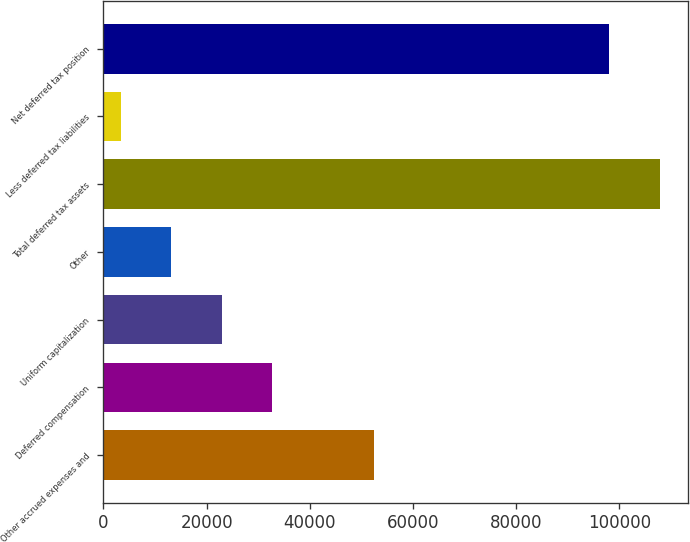<chart> <loc_0><loc_0><loc_500><loc_500><bar_chart><fcel>Other accrued expenses and<fcel>Deferred compensation<fcel>Uniform capitalization<fcel>Other<fcel>Total deferred tax assets<fcel>Less deferred tax liabilities<fcel>Net deferred tax position<nl><fcel>52384<fcel>32728<fcel>22926<fcel>13124<fcel>107822<fcel>3322<fcel>98020<nl></chart> 